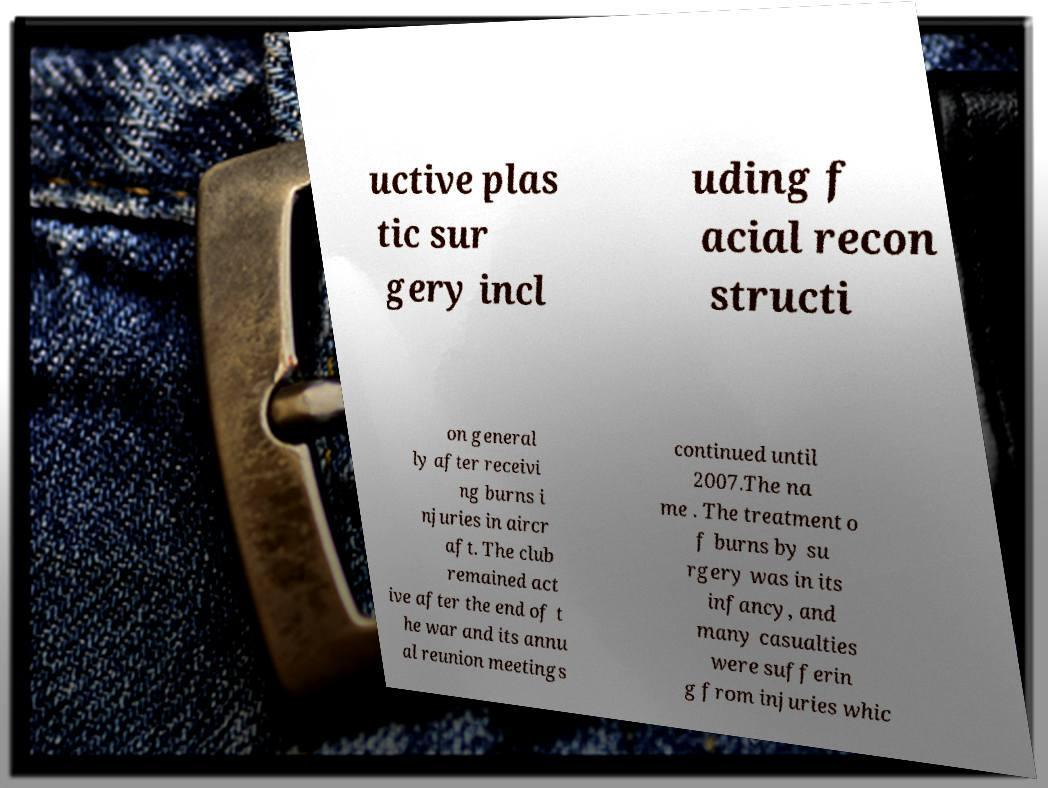Please read and relay the text visible in this image. What does it say? uctive plas tic sur gery incl uding f acial recon structi on general ly after receivi ng burns i njuries in aircr aft. The club remained act ive after the end of t he war and its annu al reunion meetings continued until 2007.The na me . The treatment o f burns by su rgery was in its infancy, and many casualties were sufferin g from injuries whic 